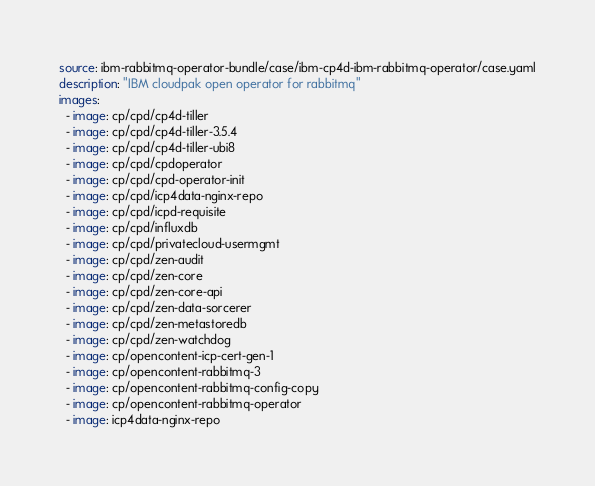Convert code to text. <code><loc_0><loc_0><loc_500><loc_500><_YAML_>source: ibm-rabbitmq-operator-bundle/case/ibm-cp4d-ibm-rabbitmq-operator/case.yaml
description: "IBM cloudpak open operator for rabbitmq"
images:
  - image: cp/cpd/cp4d-tiller
  - image: cp/cpd/cp4d-tiller-3.5.4
  - image: cp/cpd/cp4d-tiller-ubi8
  - image: cp/cpd/cpdoperator
  - image: cp/cpd/cpd-operator-init
  - image: cp/cpd/icp4data-nginx-repo
  - image: cp/cpd/icpd-requisite
  - image: cp/cpd/influxdb
  - image: cp/cpd/privatecloud-usermgmt
  - image: cp/cpd/zen-audit
  - image: cp/cpd/zen-core
  - image: cp/cpd/zen-core-api
  - image: cp/cpd/zen-data-sorcerer
  - image: cp/cpd/zen-metastoredb
  - image: cp/cpd/zen-watchdog
  - image: cp/opencontent-icp-cert-gen-1
  - image: cp/opencontent-rabbitmq-3
  - image: cp/opencontent-rabbitmq-config-copy
  - image: cp/opencontent-rabbitmq-operator
  - image: icp4data-nginx-repo
</code> 